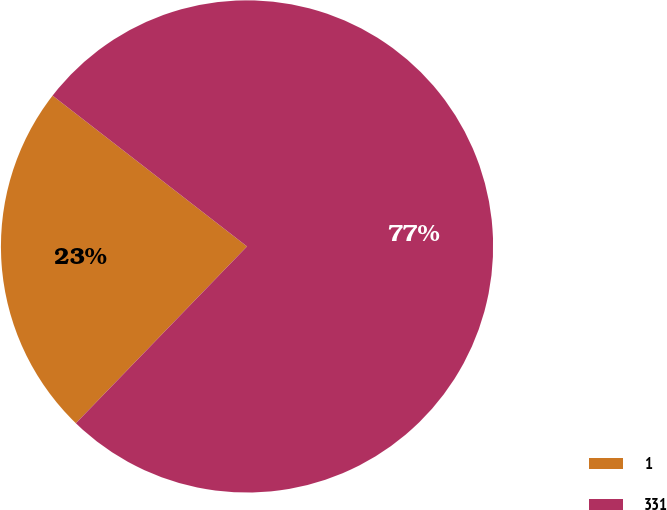<chart> <loc_0><loc_0><loc_500><loc_500><pie_chart><fcel>1<fcel>331<nl><fcel>23.26%<fcel>76.74%<nl></chart> 